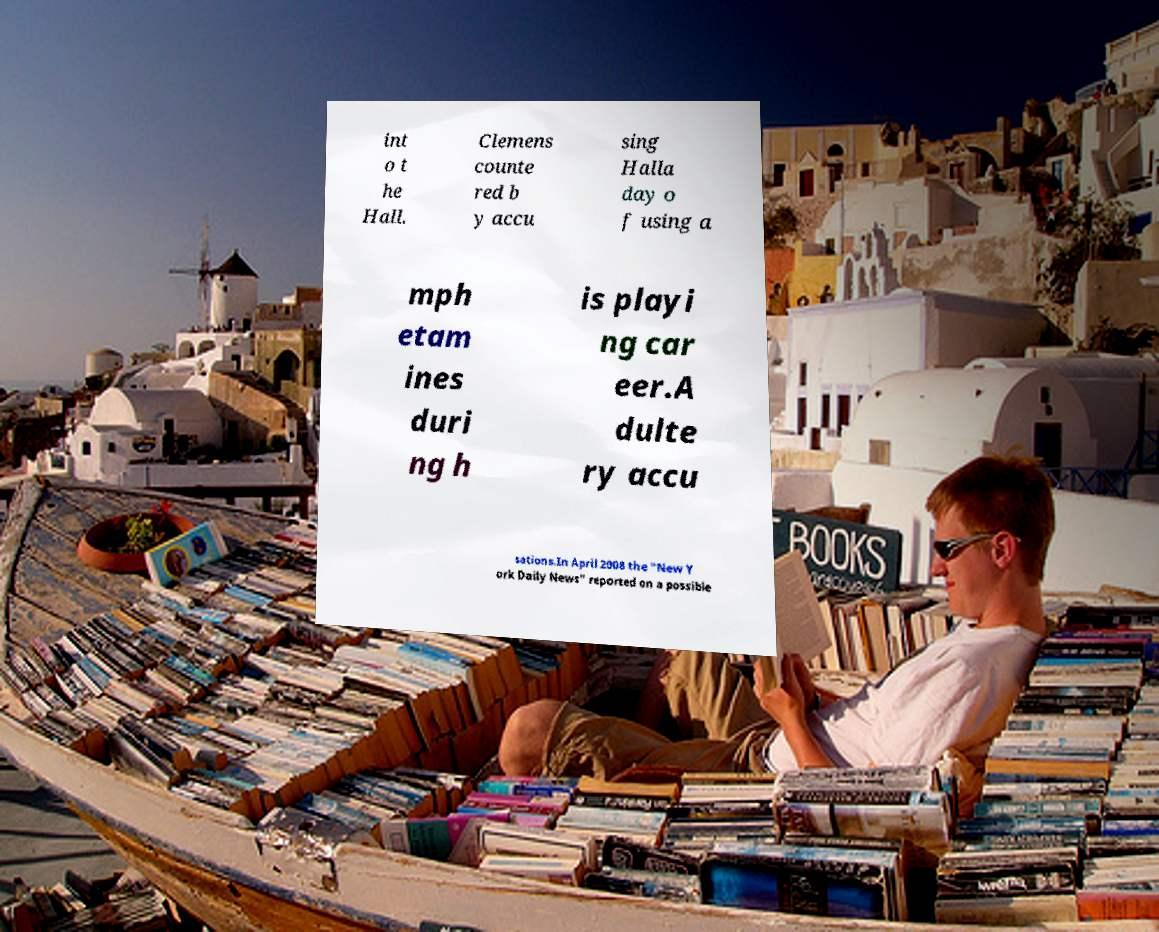I need the written content from this picture converted into text. Can you do that? int o t he Hall. Clemens counte red b y accu sing Halla day o f using a mph etam ines duri ng h is playi ng car eer.A dulte ry accu sations.In April 2008 the "New Y ork Daily News" reported on a possible 